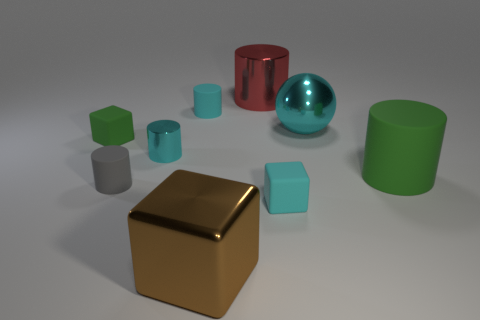Does the large matte cylinder have the same color as the large thing left of the red metal thing?
Your answer should be compact. No. The big thing that is both behind the small metal cylinder and on the left side of the big cyan shiny object is made of what material?
Provide a short and direct response. Metal. Are there any gray objects of the same size as the green cylinder?
Give a very brief answer. No. There is a green thing that is the same size as the cyan metal sphere; what is it made of?
Your answer should be compact. Rubber. How many blocks are behind the big metallic cube?
Ensure brevity in your answer.  2. Is the shape of the green thing that is on the left side of the big metal cube the same as  the brown thing?
Your answer should be very brief. Yes. Are there any other big green matte things of the same shape as the big green matte thing?
Ensure brevity in your answer.  No. What material is the small cube that is the same color as the big rubber cylinder?
Keep it short and to the point. Rubber. What is the shape of the cyan shiny thing to the right of the small matte cube in front of the big rubber cylinder?
Make the answer very short. Sphere. How many cubes have the same material as the small gray cylinder?
Offer a very short reply. 2. 